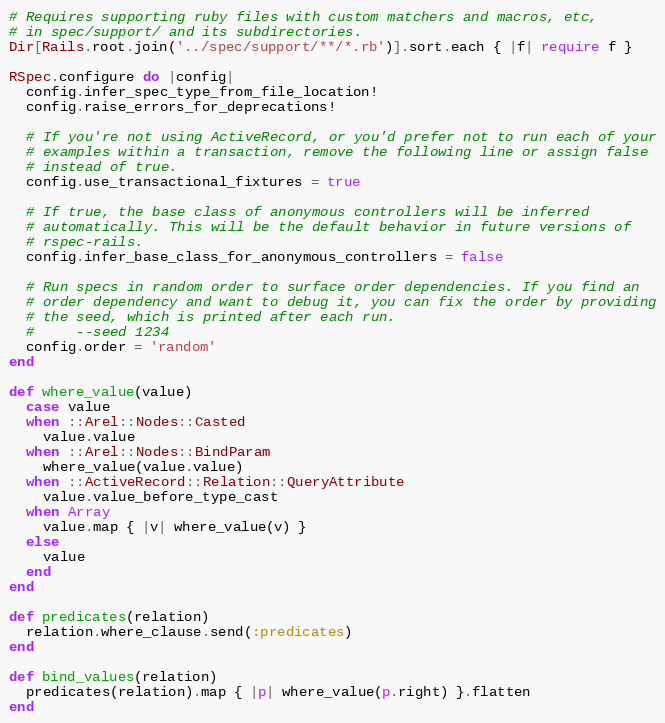Convert code to text. <code><loc_0><loc_0><loc_500><loc_500><_Ruby_># Requires supporting ruby files with custom matchers and macros, etc,
# in spec/support/ and its subdirectories.
Dir[Rails.root.join('../spec/support/**/*.rb')].sort.each { |f| require f }

RSpec.configure do |config|
  config.infer_spec_type_from_file_location!
  config.raise_errors_for_deprecations!

  # If you're not using ActiveRecord, or you'd prefer not to run each of your
  # examples within a transaction, remove the following line or assign false
  # instead of true.
  config.use_transactional_fixtures = true

  # If true, the base class of anonymous controllers will be inferred
  # automatically. This will be the default behavior in future versions of
  # rspec-rails.
  config.infer_base_class_for_anonymous_controllers = false

  # Run specs in random order to surface order dependencies. If you find an
  # order dependency and want to debug it, you can fix the order by providing
  # the seed, which is printed after each run.
  #     --seed 1234
  config.order = 'random'
end

def where_value(value)
  case value
  when ::Arel::Nodes::Casted
    value.value
  when ::Arel::Nodes::BindParam
    where_value(value.value)
  when ::ActiveRecord::Relation::QueryAttribute
    value.value_before_type_cast
  when Array
    value.map { |v| where_value(v) }
  else
    value
  end
end

def predicates(relation)
  relation.where_clause.send(:predicates)
end

def bind_values(relation)
  predicates(relation).map { |p| where_value(p.right) }.flatten
end
</code> 